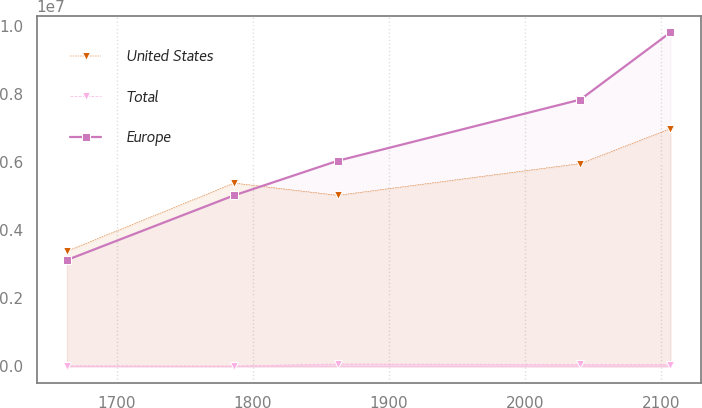Convert chart. <chart><loc_0><loc_0><loc_500><loc_500><line_chart><ecel><fcel>United States<fcel>Total<fcel>Europe<nl><fcel>1663.14<fcel>3.38235e+06<fcel>18309.1<fcel>3.12245e+06<nl><fcel>1786.15<fcel>5.37961e+06<fcel>12554.7<fcel>5.01916e+06<nl><fcel>1862.41<fcel>5.0201e+06<fcel>70098.6<fcel>6.03365e+06<nl><fcel>2040.84<fcel>5.9528e+06<fcel>57167<fcel>7.82807e+06<nl><fcel>2107.21<fcel>6.97744e+06<fcel>51200.5<fcel>9.80113e+06<nl></chart> 